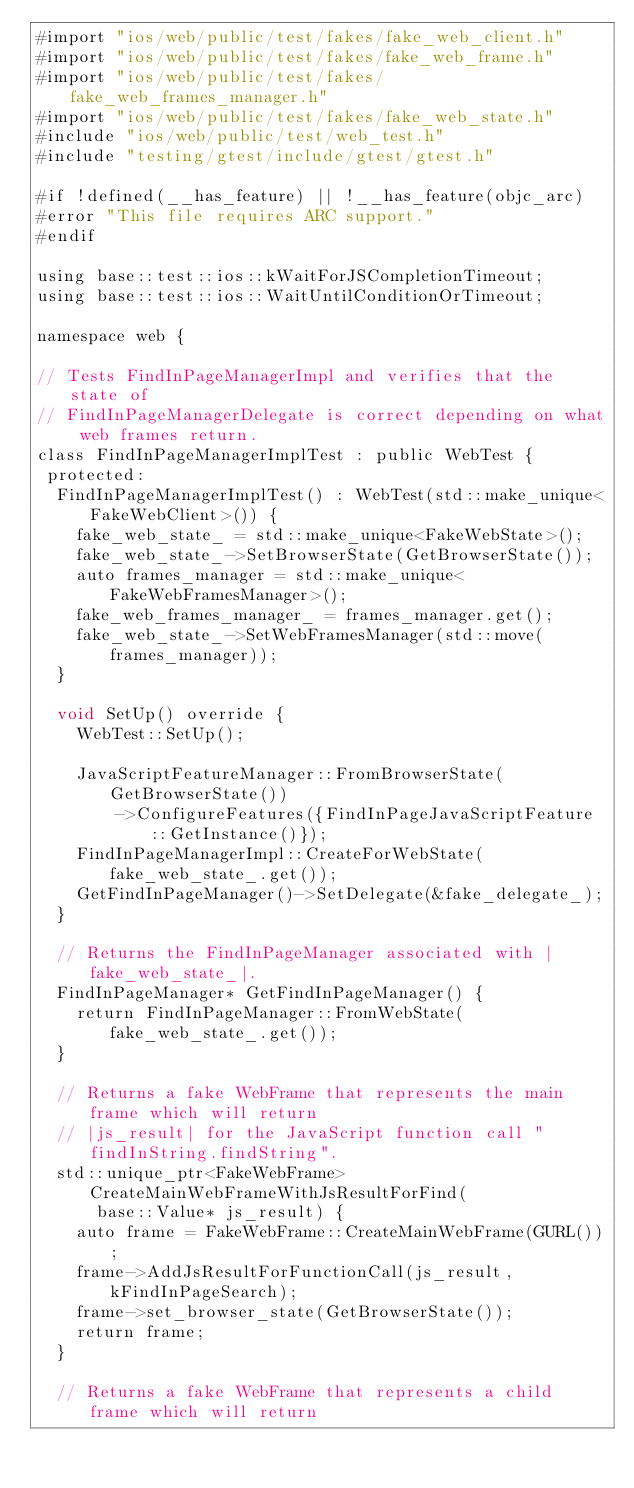<code> <loc_0><loc_0><loc_500><loc_500><_ObjectiveC_>#import "ios/web/public/test/fakes/fake_web_client.h"
#import "ios/web/public/test/fakes/fake_web_frame.h"
#import "ios/web/public/test/fakes/fake_web_frames_manager.h"
#import "ios/web/public/test/fakes/fake_web_state.h"
#include "ios/web/public/test/web_test.h"
#include "testing/gtest/include/gtest/gtest.h"

#if !defined(__has_feature) || !__has_feature(objc_arc)
#error "This file requires ARC support."
#endif

using base::test::ios::kWaitForJSCompletionTimeout;
using base::test::ios::WaitUntilConditionOrTimeout;

namespace web {

// Tests FindInPageManagerImpl and verifies that the state of
// FindInPageManagerDelegate is correct depending on what web frames return.
class FindInPageManagerImplTest : public WebTest {
 protected:
  FindInPageManagerImplTest() : WebTest(std::make_unique<FakeWebClient>()) {
    fake_web_state_ = std::make_unique<FakeWebState>();
    fake_web_state_->SetBrowserState(GetBrowserState());
    auto frames_manager = std::make_unique<FakeWebFramesManager>();
    fake_web_frames_manager_ = frames_manager.get();
    fake_web_state_->SetWebFramesManager(std::move(frames_manager));
  }

  void SetUp() override {
    WebTest::SetUp();

    JavaScriptFeatureManager::FromBrowserState(GetBrowserState())
        ->ConfigureFeatures({FindInPageJavaScriptFeature::GetInstance()});
    FindInPageManagerImpl::CreateForWebState(fake_web_state_.get());
    GetFindInPageManager()->SetDelegate(&fake_delegate_);
  }

  // Returns the FindInPageManager associated with |fake_web_state_|.
  FindInPageManager* GetFindInPageManager() {
    return FindInPageManager::FromWebState(fake_web_state_.get());
  }

  // Returns a fake WebFrame that represents the main frame which will return
  // |js_result| for the JavaScript function call "findInString.findString".
  std::unique_ptr<FakeWebFrame> CreateMainWebFrameWithJsResultForFind(
      base::Value* js_result) {
    auto frame = FakeWebFrame::CreateMainWebFrame(GURL());
    frame->AddJsResultForFunctionCall(js_result, kFindInPageSearch);
    frame->set_browser_state(GetBrowserState());
    return frame;
  }

  // Returns a fake WebFrame that represents a child frame which will return</code> 